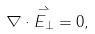Convert formula to latex. <formula><loc_0><loc_0><loc_500><loc_500>\nabla \cdot \overset { \rightharpoonup } { E _ { \bot } } = 0 ,</formula> 